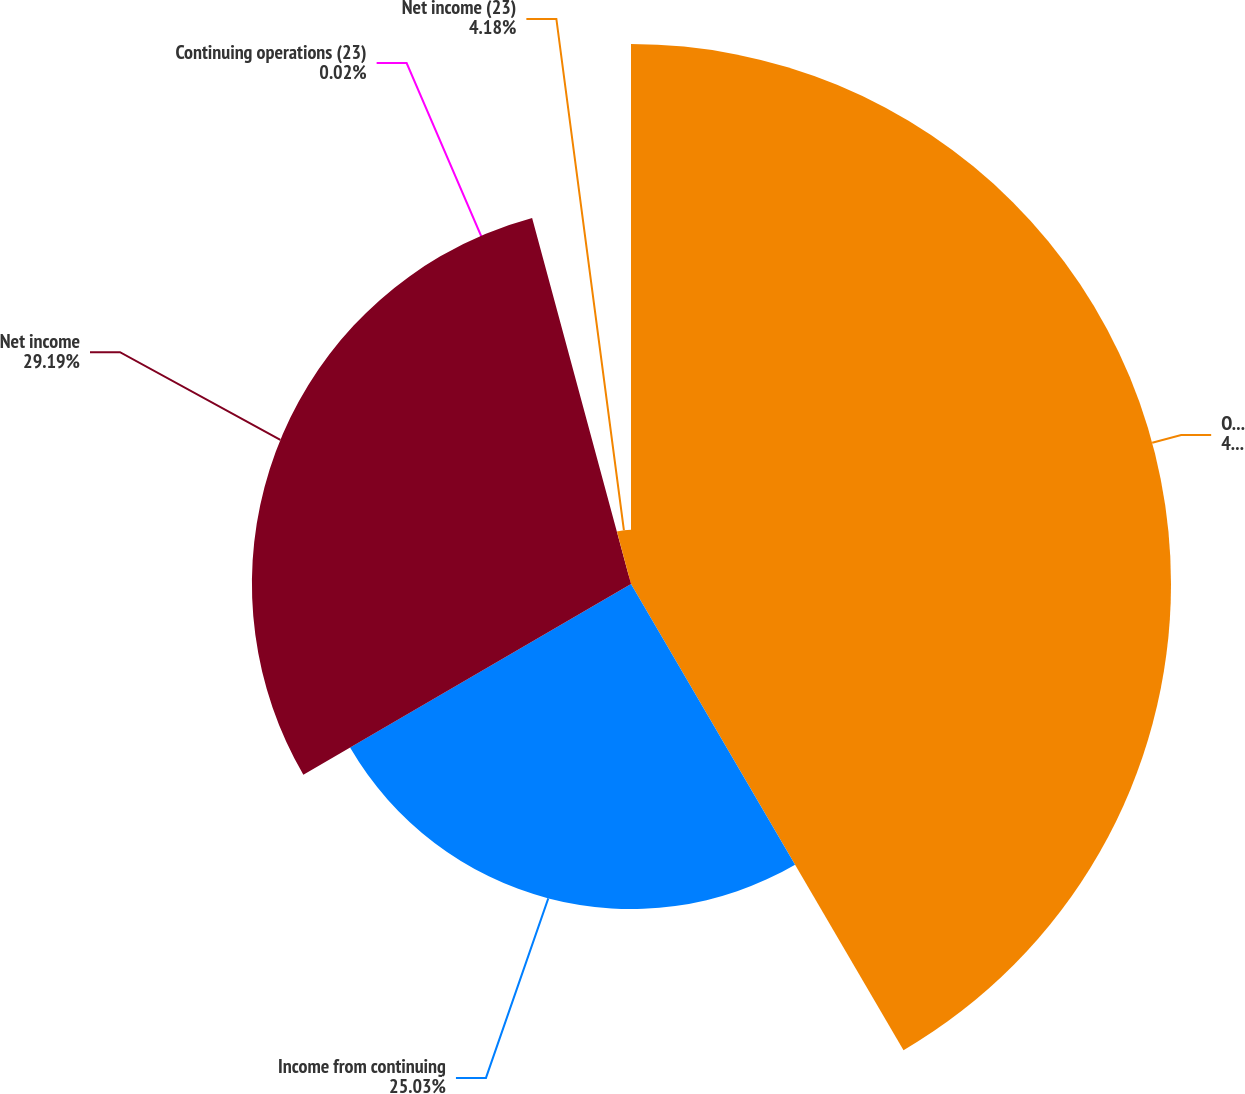Convert chart. <chart><loc_0><loc_0><loc_500><loc_500><pie_chart><fcel>Operating income<fcel>Income from continuing<fcel>Net income<fcel>Continuing operations (23)<fcel>Net income (23)<nl><fcel>41.58%<fcel>25.03%<fcel>29.19%<fcel>0.02%<fcel>4.18%<nl></chart> 